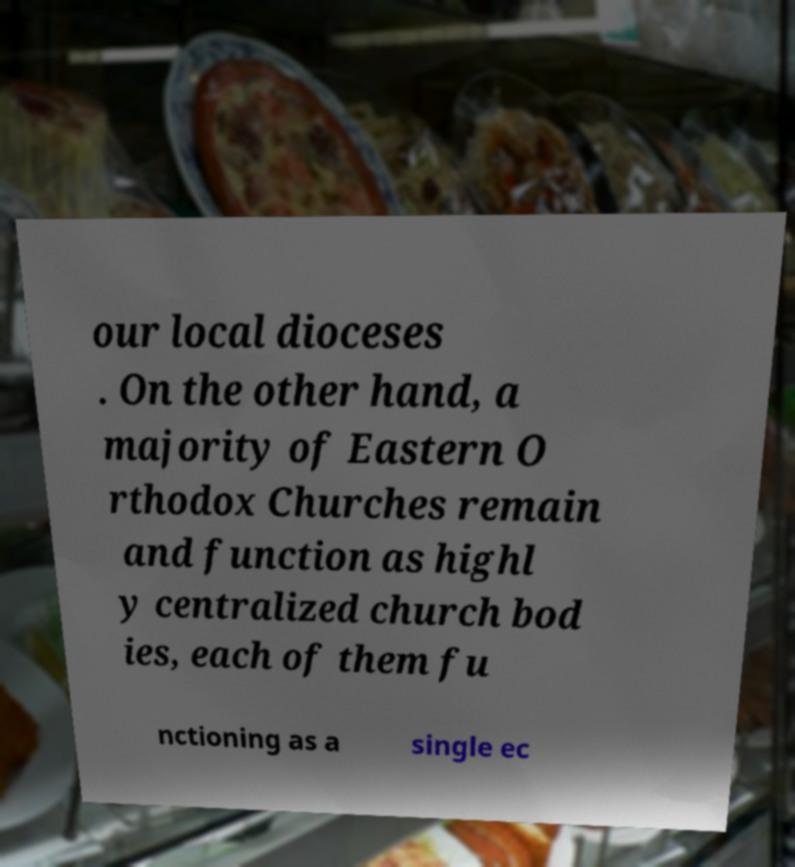Could you assist in decoding the text presented in this image and type it out clearly? our local dioceses . On the other hand, a majority of Eastern O rthodox Churches remain and function as highl y centralized church bod ies, each of them fu nctioning as a single ec 